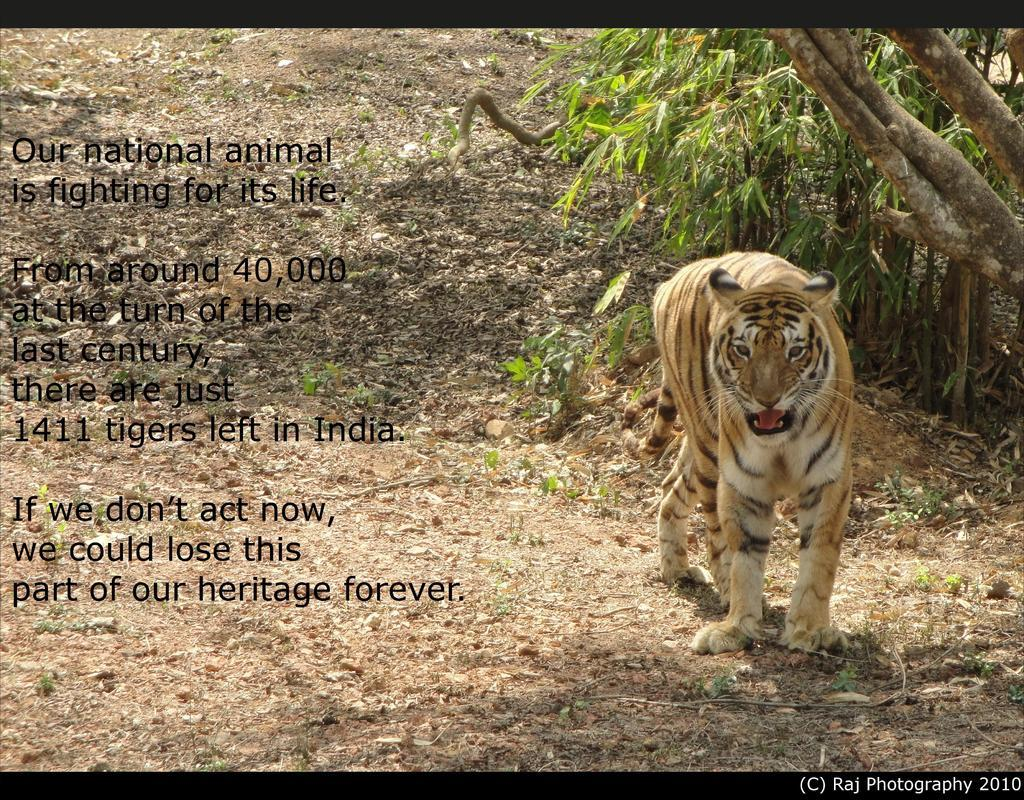What type of image is being described? The image is a poster. What animal is featured in the poster? There is a tiger standing in the image. What type of natural environment is depicted in the poster? There are trees in the image. What else can be found on the poster besides the tiger and trees? There are letters and a watermark in the bottom right corner of the image. How many brothers are standing next to the tiger in the image? There are no brothers present in the image; it features a tiger standing alone. What type of twist can be seen in the image? There is no twist present in the image; it is a poster with a tiger, trees, letters, and a watermark. 